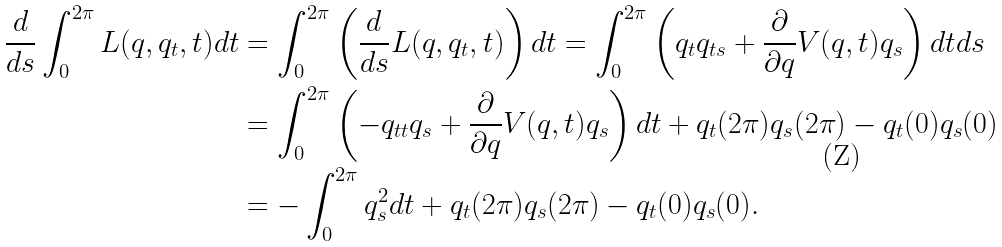Convert formula to latex. <formula><loc_0><loc_0><loc_500><loc_500>\frac { d } { d s } \int _ { 0 } ^ { 2 \pi } L ( q , q _ { t } , t ) d t & = \int _ { 0 } ^ { 2 \pi } \left ( \frac { d } { d s } L ( q , q _ { t } , t ) \right ) d t = \int _ { 0 } ^ { 2 \pi } \left ( q _ { t } q _ { t s } + \frac { \partial } { \partial q } V ( q , t ) q _ { s } \right ) d t d s \\ & = \int _ { 0 } ^ { 2 \pi } \left ( - q _ { t t } q _ { s } + \frac { \partial } { \partial q } V ( q , t ) q _ { s } \right ) d t + q _ { t } ( 2 \pi ) q _ { s } ( 2 \pi ) - q _ { t } ( 0 ) q _ { s } ( 0 ) \\ & = - \int _ { 0 } ^ { 2 \pi } q _ { s } ^ { 2 } d t + q _ { t } ( 2 \pi ) q _ { s } ( 2 \pi ) - q _ { t } ( 0 ) q _ { s } ( 0 ) .</formula> 